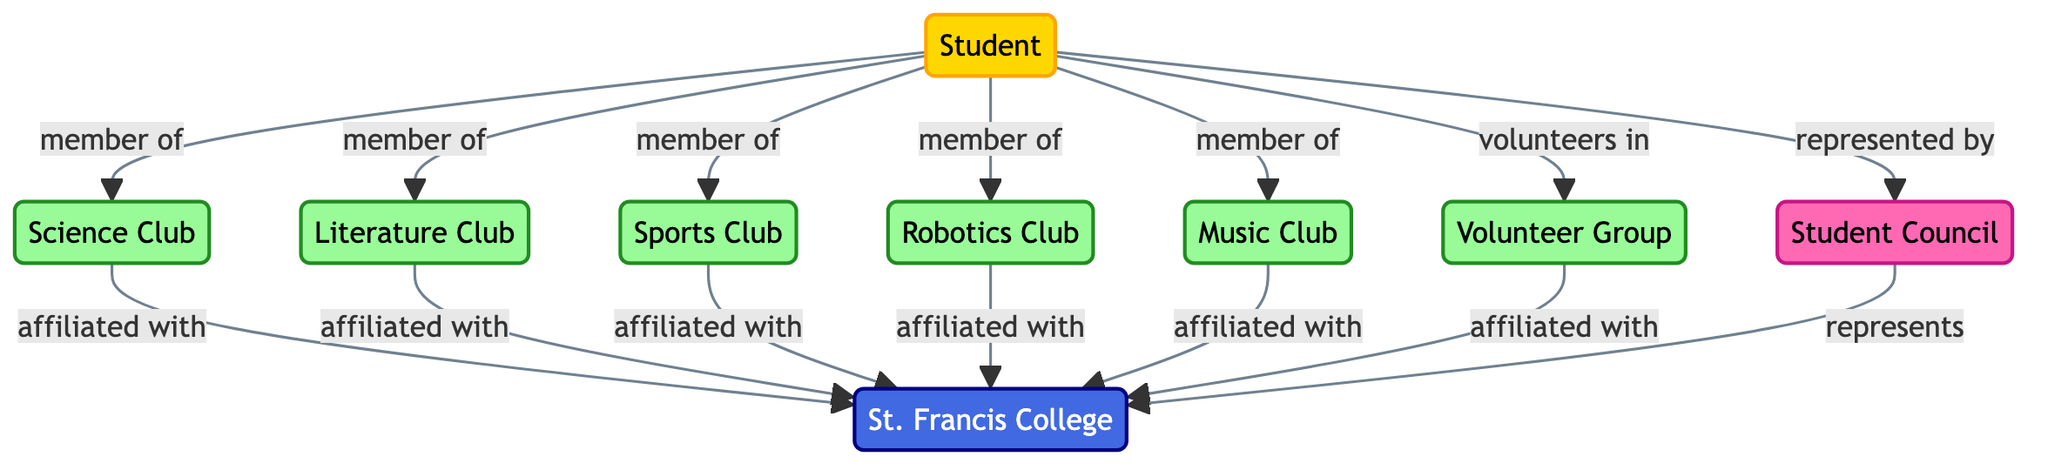What is the total number of nodes in the diagram? The nodes in the diagram include: student, St. Francis College, Science Club, Literature Club, Sports Club, Robotics Club, Music Club, Volunteer Group, and Student Council. Counting these gives us a total of 9 nodes.
Answer: 9 Which club is the student a member of that focuses on technology? The diagram shows that the student is a member of the Robotics Club, which focuses on technology.
Answer: Robotics Club How many clubs are affiliated with St. Francis College? The clubs that are affiliated with St. Francis College are the Science Club, Literature Club, Sports Club, Robotics Club, Music Club, and Volunteer Group. Counting these gives a total of 6 clubs.
Answer: 6 What role does the Student Council play in relation to St. Francis College? The Student Council represents St. Francis College according to the diagram, demonstrating its role as a representative body.
Answer: represents Which club does the student volunteer in? According to the diagram, the student volunteers in the Volunteer Group, where they are engaged in helping others.
Answer: Volunteer Group How many different types of connections are shown in the diagram? The diagram displays three types of connections: "member of," "affiliated with," and "represents." Counting these gives us a total of 3 different connection types.
Answer: 3 What is the relationship between the student and the Student Council? The relationship between the student and the Student Council is that the student is represented by the Student Council, indicating a direct connection between the two.
Answer: represented by Which organization is directly connected to the student and focuses on literature? The Literature Club is directly connected to the student as a club the student is a member of and focuses on literature activities.
Answer: Literature Club What color represents the clubs in the diagram? The clubs are represented by the color light green, as indicated by the class definition for the club nodes in the diagram.
Answer: light green 